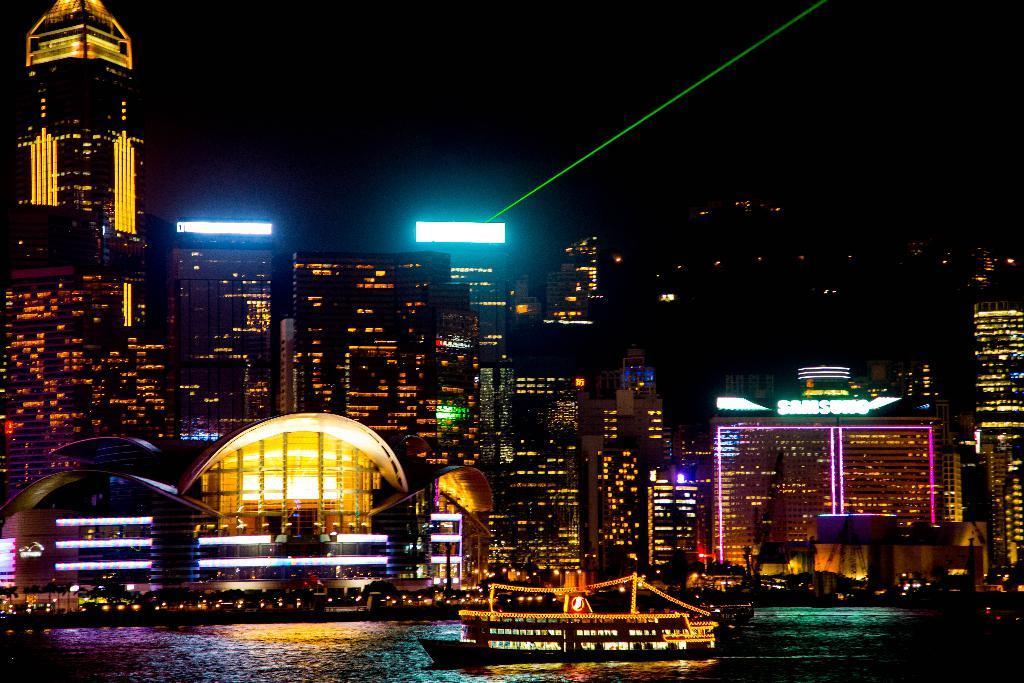Can you describe this image briefly? It is a beautiful night view of a city there are plenty of buildings and organisations and there is a ship moving on the water surface in the front, the picture is very colorful. 